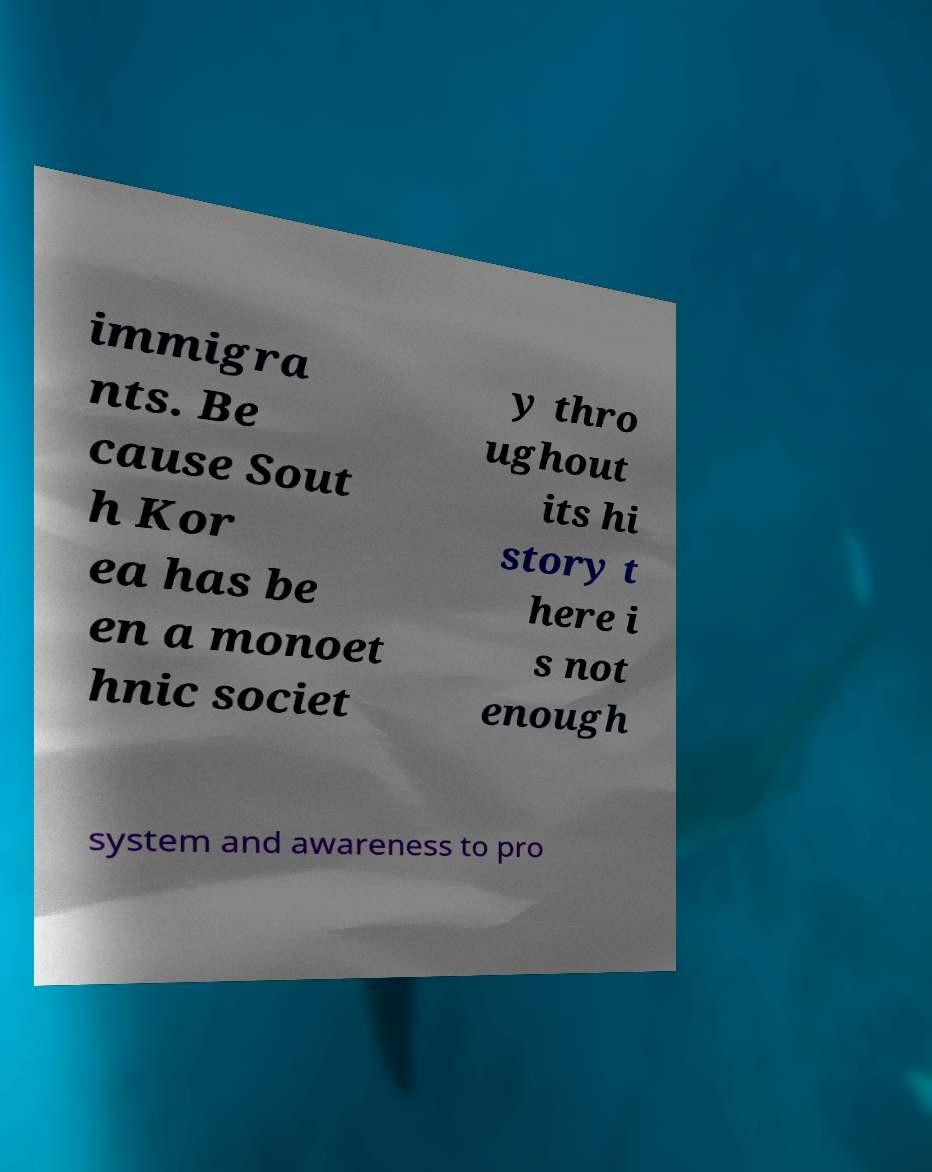For documentation purposes, I need the text within this image transcribed. Could you provide that? immigra nts. Be cause Sout h Kor ea has be en a monoet hnic societ y thro ughout its hi story t here i s not enough system and awareness to pro 